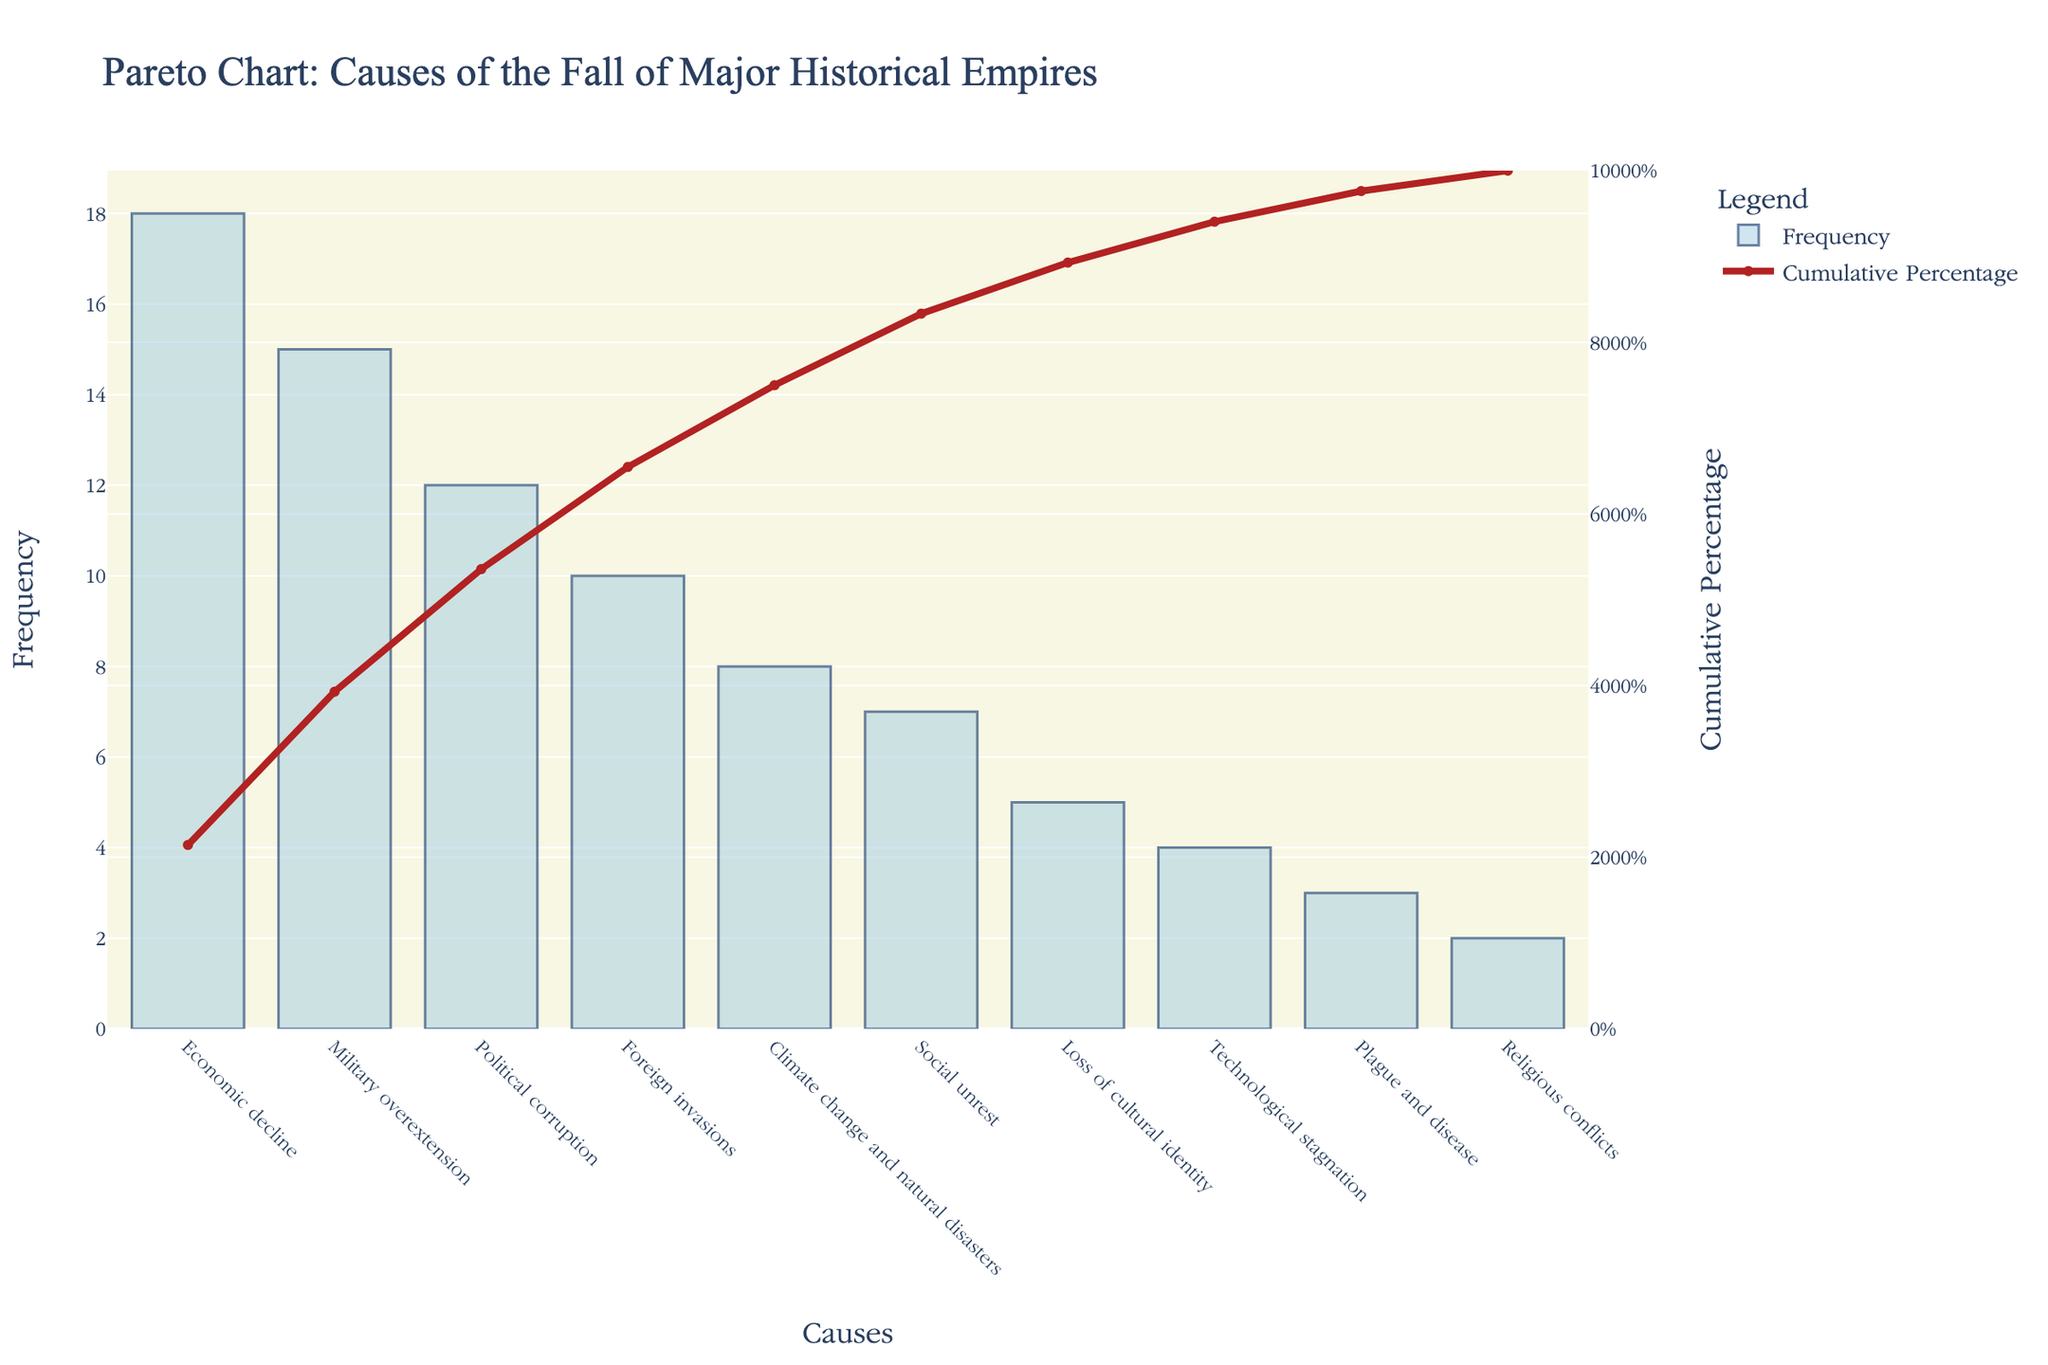What is the title of the figure? The title of the figure is usually positioned at the top of the plot, providing a brief description of the chart's content. In this case, the title reads "Pareto Chart: Causes of the Fall of Major Historical Empires".
Answer: Pareto Chart: Causes of the Fall of Major Historical Empires How many causes of the fall of major historical empires are listed in the figure? To determine the number of causes listed, one would count the bars in the bar chart corresponding to each cause.
Answer: 10 Which cause has the highest frequency? The cause with the highest frequency is represented by the tallest bar in the bar chart. The tallest bar is for "Economic decline" with a frequency of 18.
Answer: Economic decline What is the cumulative percentage of the top three causes combined? Calculate the cumulative frequencies of the top three causes: "Economic decline" (18), "Military overextension" (15), and "Political corruption" (12). Add these to get a sum of 45. Determine the total frequencies of all causes (84). Divide the sum (45) by total (84) and multiply by 100 to get the cumulative percentage: (45/84) * 100 ≈ 53.57%.
Answer: 53.57% Which cause contributes exactly 50% to the cumulative percentage? By examining the cumulative percentage line, one can see that "Military overextension", which is the second bar after "Economic decline", brings the cumulative percentage close to 50%. The exact percentages can be cross-verified by the cumulative percentage values marked along the secondary y-axis.
Answer: Military overextension What frequency is associated with the least cause? The cause with the least frequency is represented by the shortest bar in the bar chart. The shortest bar is for "Religious conflicts" with a frequency of 2.
Answer: 2 How does the frequency of "Foreign invasions" compare to "Political corruption"? Compare the heights of the bars for "Foreign invasions" and "Political corruption". The frequency of "Political corruption" is 12, while "Foreign invasions" is 10. So, "Political corruption" is higher.
Answer: Political corruption is higher What percentage of the causes is explained by the top two causes? Sum the frequencies of the top two causes: "Economic decline" (18) and "Military overextension" (15). The sum is 33. Divide this by the total frequency (84) and multiply by 100 to get the percentage: (33/84) * 100 ≈ 39.29%.
Answer: 39.29% What is the cumulative percentage after the first five causes? The cumulative frequency after the first five causes is the sum of their frequencies: "Economic decline" (18), "Military overextension" (15), "Political corruption" (12), "Foreign invasions" (10), "Climate change and natural disasters" (8). Add these up to get 63. Divide by the total frequency 84 and multiply by 100 to get the cumulative percentage: (63/84) * 100 ≈ 75%.
Answer: 75% What cause has a frequency of 7, and what is its contribution to the cumulative percentage? Referring to the bar chart, find the cause with a frequency of 7, which is "Social unrest". To find its contribution: Sum the previous frequencies (18 + 15 + 12 + 10 + 8) = 63, then add 7 (total 70). Divide by 84 and multiply by 100: (70/84) * 100 ≈ 83.33%.
Answer: Social unrest, 83.33% 